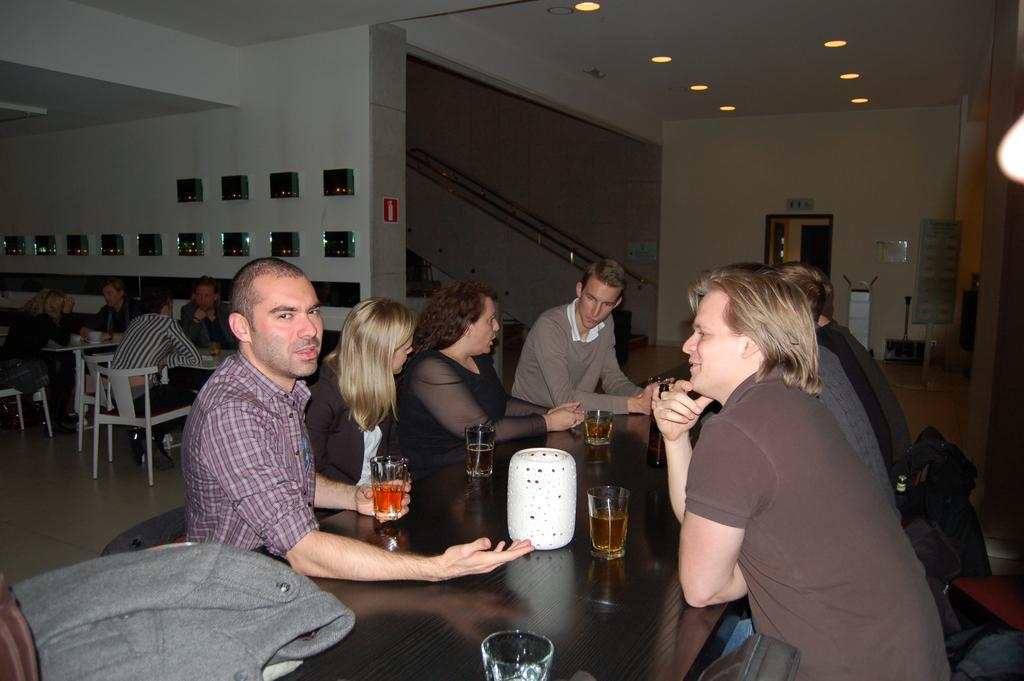What are the people in the image doing? The persons in the image are sitting on chairs. What is on the table in the image? There are glasses on the table. What is the background of the image? There is a wall in the background of the image. What can be seen illuminating the scene? There are lights visible in the image. Are there any matches or masks on the table in the image? No, there are no matches or masks present on the table in the image. Is there a goat visible in the image? No, there is no goat present in the image. 